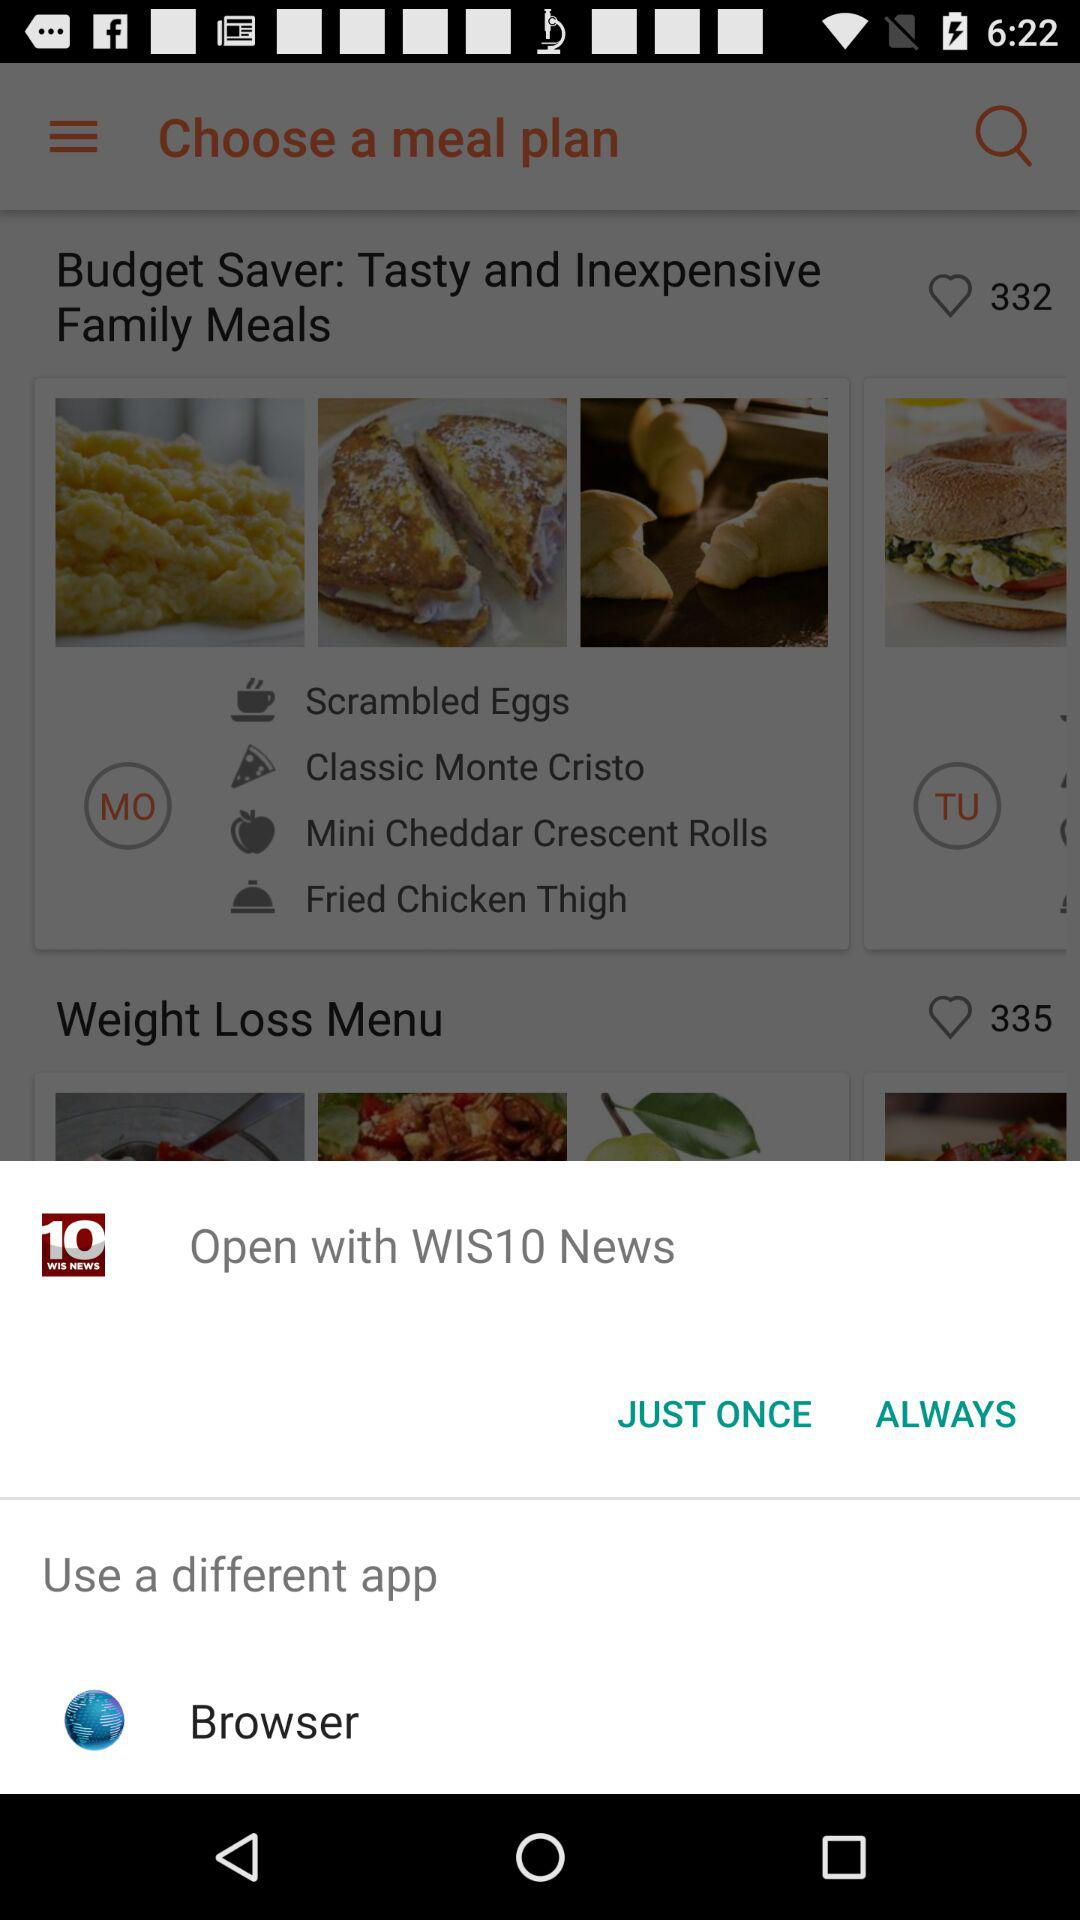How many likes are there of the "Budget Saver" meal plan? There are 332 likes of the "Budget Saver" meal plan. 